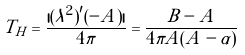Convert formula to latex. <formula><loc_0><loc_0><loc_500><loc_500>T _ { H } = \frac { | ( \lambda ^ { 2 } ) ^ { \prime } ( - A ) | } { 4 \pi } = \frac { B - A } { 4 \pi A ( A - \alpha ) }</formula> 